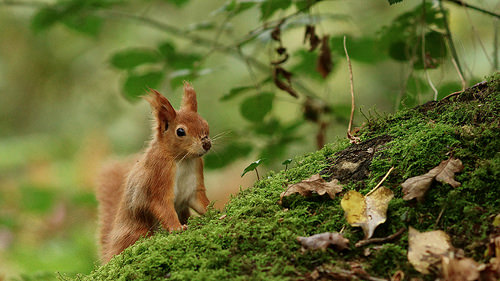<image>
Is there a grass behind the animal? No. The grass is not behind the animal. From this viewpoint, the grass appears to be positioned elsewhere in the scene. Is the squirrel in front of the leaf? No. The squirrel is not in front of the leaf. The spatial positioning shows a different relationship between these objects. 